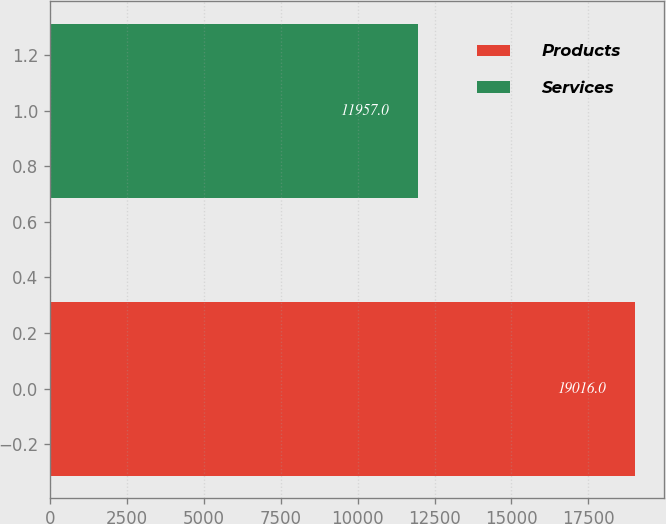Convert chart. <chart><loc_0><loc_0><loc_500><loc_500><bar_chart><fcel>Products<fcel>Services<nl><fcel>19016<fcel>11957<nl></chart> 